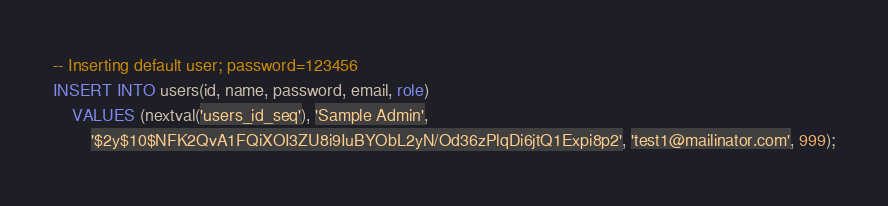<code> <loc_0><loc_0><loc_500><loc_500><_SQL_>-- Inserting default user; password=123456
INSERT INTO users(id, name, password, email, role)
    VALUES (nextval('users_id_seq'), 'Sample Admin', 
        '$2y$10$NFK2QvA1FQiXOI3ZU8i9IuBYObL2yN/Od36zPlqDi6jtQ1Expi8p2', 'test1@mailinator.com', 999);</code> 